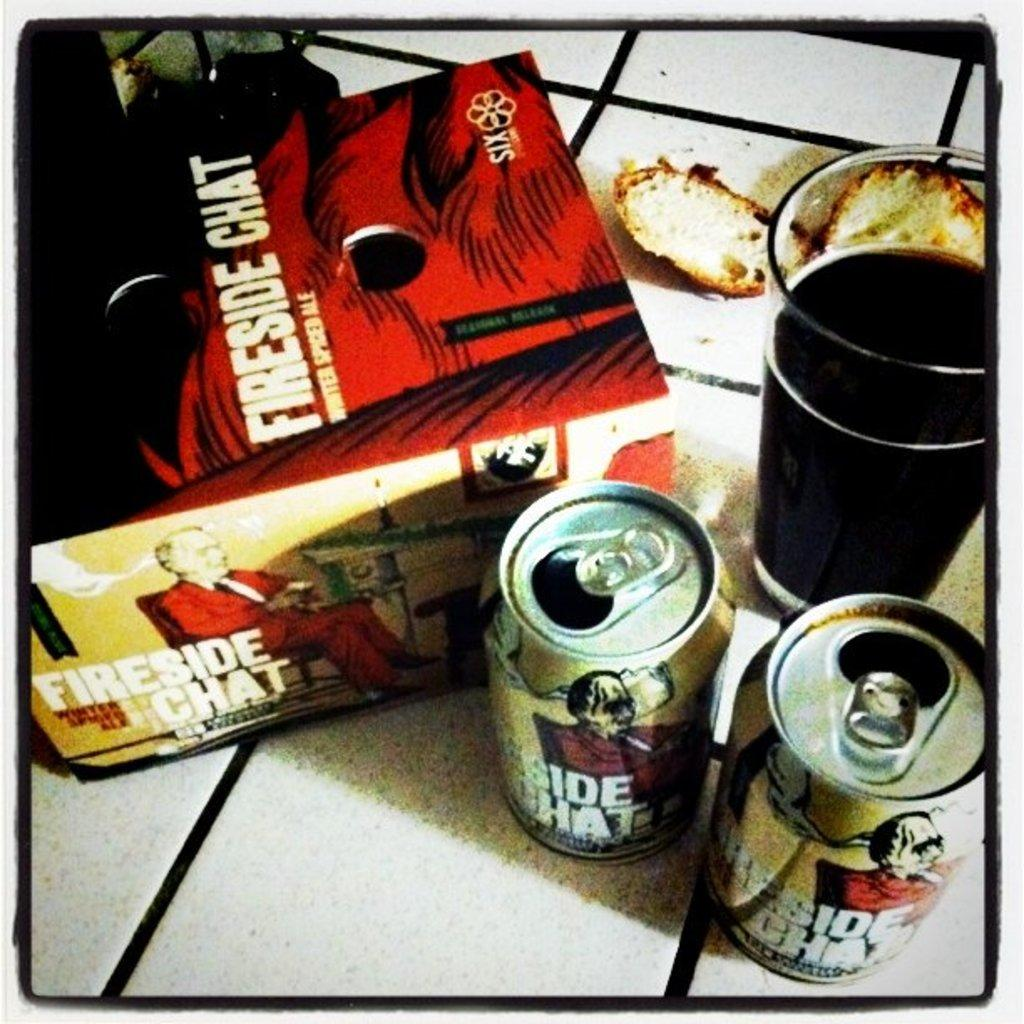Provide a one-sentence caption for the provided image. a beer box that says Fireside Chat on it. 